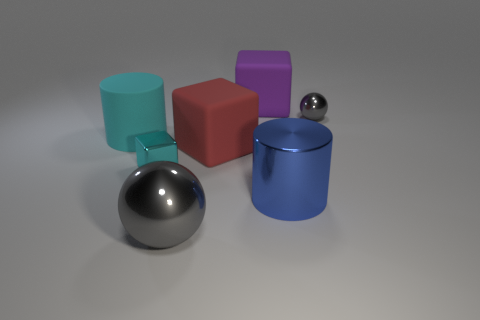Add 2 large blocks. How many objects exist? 9 Subtract all cylinders. How many objects are left? 5 Add 1 small gray spheres. How many small gray spheres exist? 2 Subtract 1 red cubes. How many objects are left? 6 Subtract all big cyan rubber things. Subtract all big blue metallic things. How many objects are left? 5 Add 4 blue things. How many blue things are left? 5 